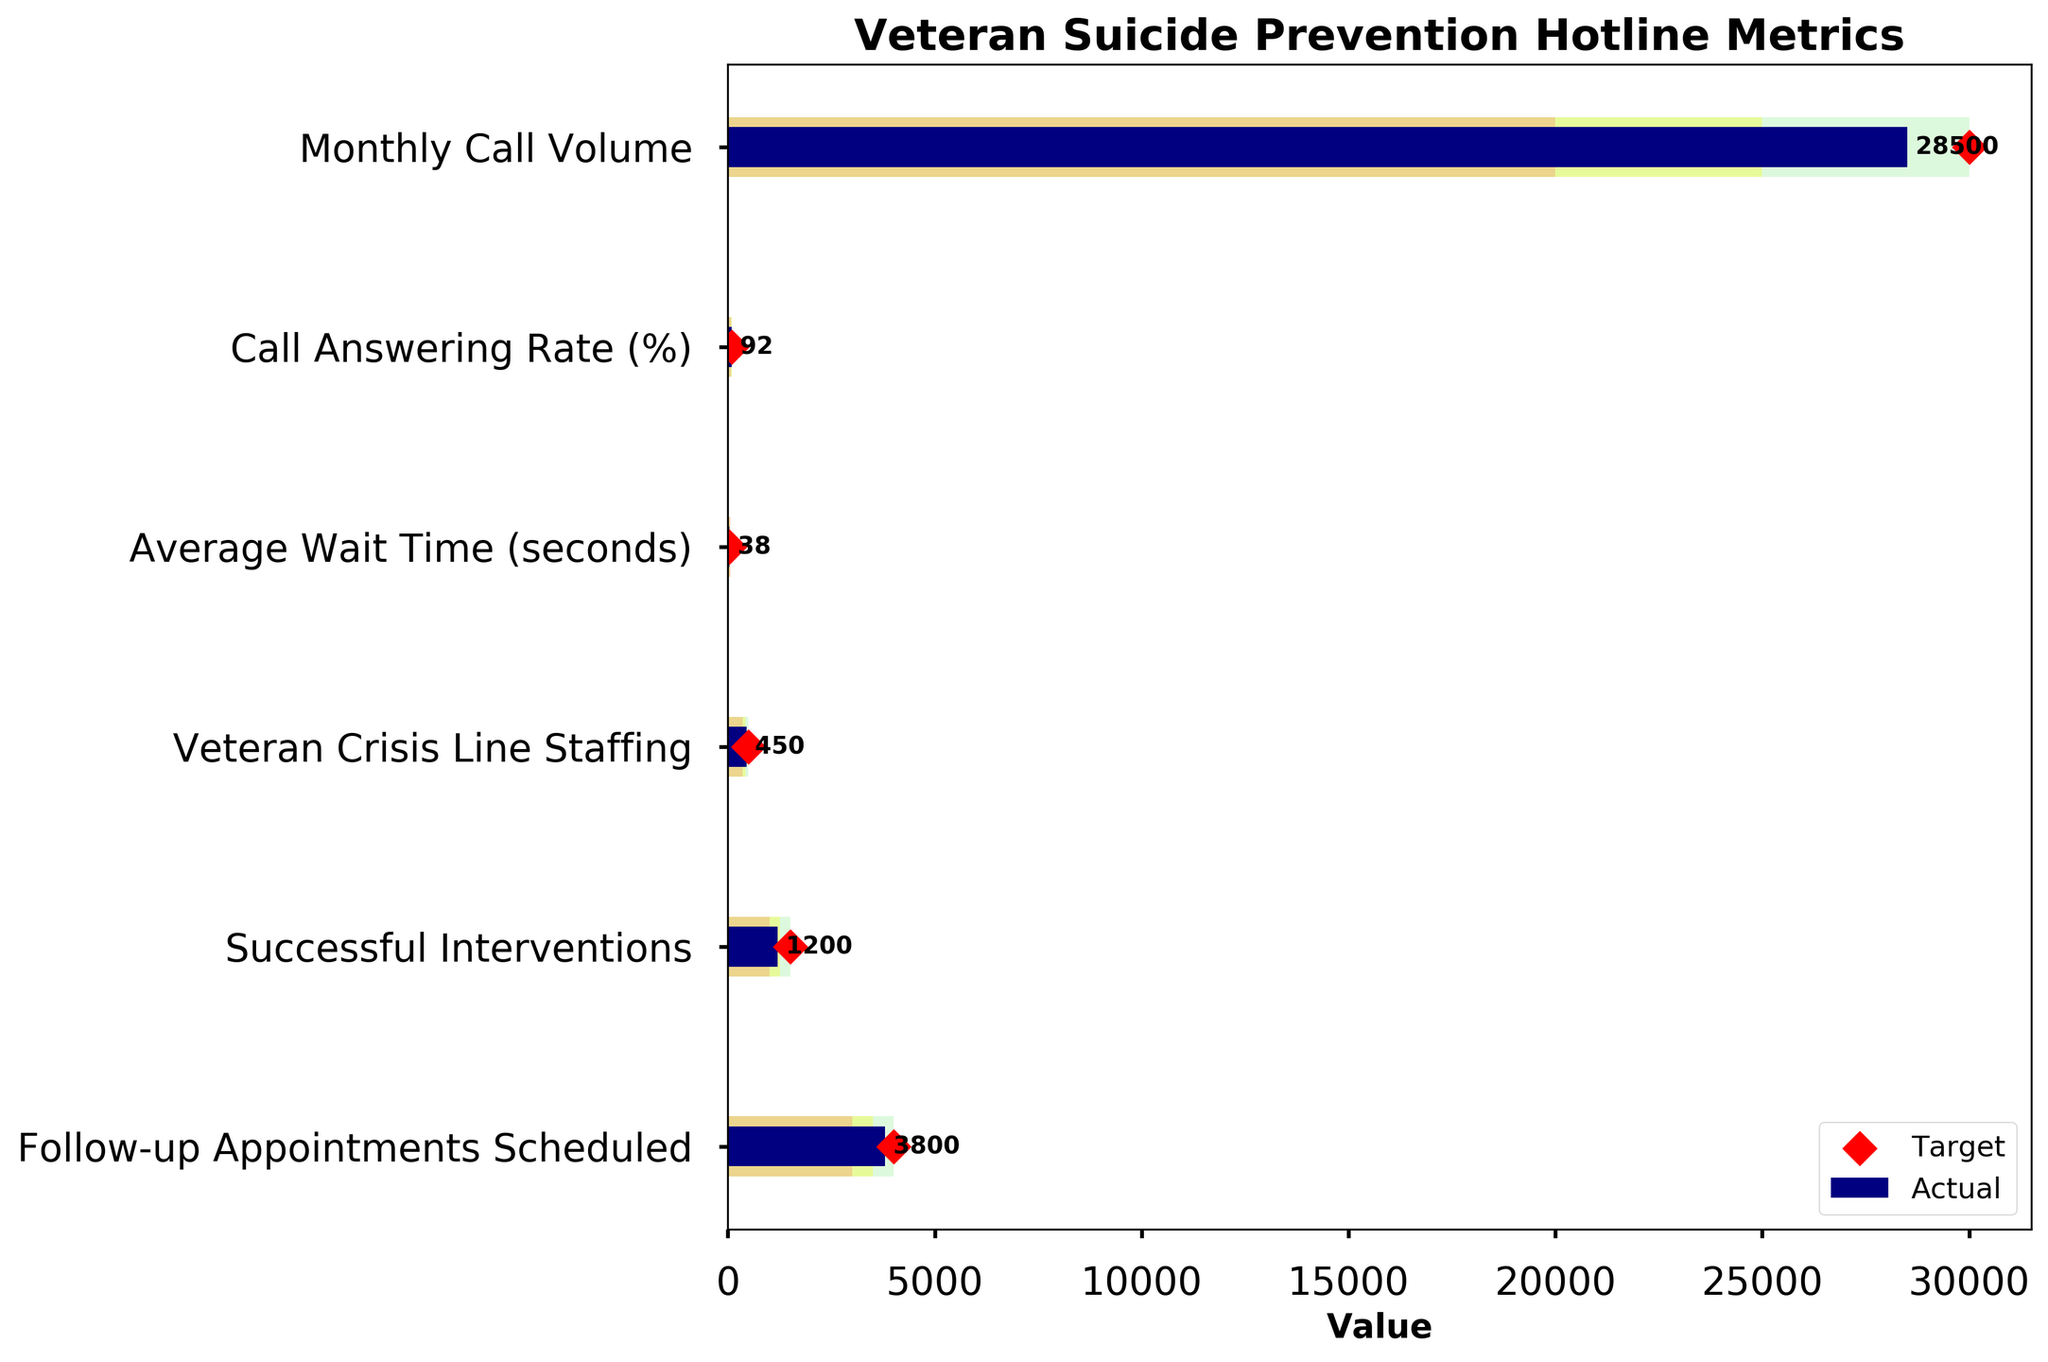What is the title of the figure? The title is usually located at the top of the figure which describes what the figure is about. In this case, it is clearly stated above the plot.
Answer: Veteran Suicide Prevention Hotline Metrics How many metrics are displayed in the figure? Count the number of different y-axis categories representing various metrics. Each horizontal bar corresponds to one metric.
Answer: Six What is the 'Actual' Monthly Call Volume? Look for the navy-colored bar corresponding to the 'Monthly Call Volume' and note its value shown on the horizontal axis.
Answer: 28500 What is the Target value for 'Call Answering Rate (%)'? Identify the red diamond marker for 'Call Answering Rate (%)' on the plot, which indicates the target value.
Answer: 95 Which metric has the highest Actual value? Compare the lengths of the navy-colored bars across all metrics to identify the longest one.
Answer: Follow-up Appointments Scheduled How much higher or lower is the Actual value for 'Monthly Call Volume' compared to its target? Subtract the Actual value from the Target value: 30000 (Target) - 28500 (Actual) = 1500.
Answer: 1500 lower What is the Average Wait Time (seconds) indicated in the plot? Locate the navy-colored bar for 'Average Wait Time (seconds)' and note its value on the horizontal axis.
Answer: 38 Which metric falls under the Poor range for its Actual value? Identify which navy-colored bar falls within the salmon area marked as the Poor range.
Answer: Average Wait Time (seconds) What is the difference between 'Veteran Crisis Line Staffing' target and actual values? Subtract the Actual value from the Target value: 500 (Target) - 450 (Actual) = 50.
Answer: 50 Which metrics achieved their Good target values? Look for navy-colored bars that either meet or exceed the Good target range (light green area). Compare this visually for each metric.
Answer: None 